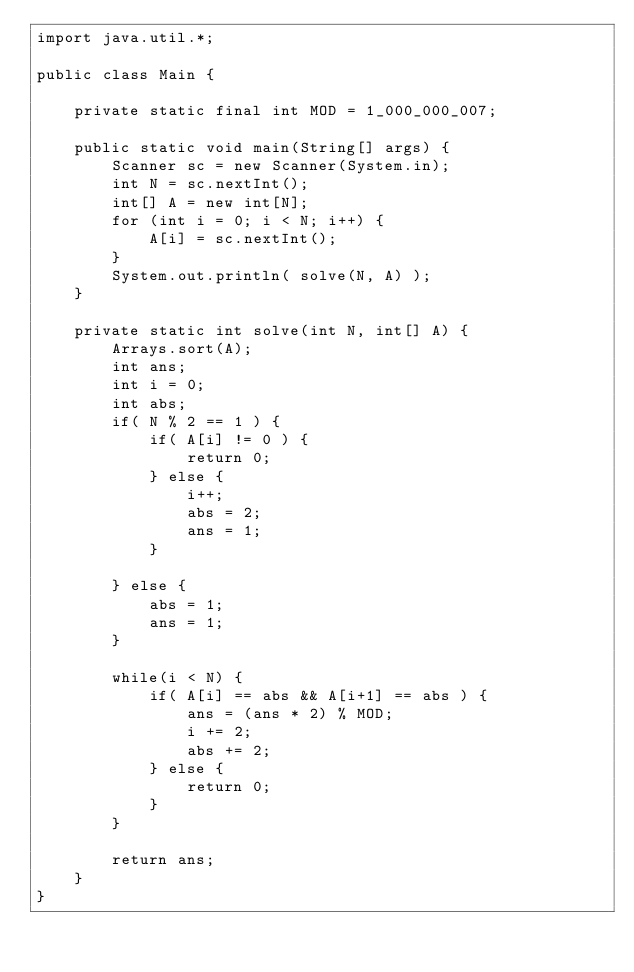Convert code to text. <code><loc_0><loc_0><loc_500><loc_500><_Java_>import java.util.*;

public class Main {

    private static final int MOD = 1_000_000_007;

    public static void main(String[] args) {
        Scanner sc = new Scanner(System.in);
        int N = sc.nextInt();
        int[] A = new int[N];
        for (int i = 0; i < N; i++) {
            A[i] = sc.nextInt();
        }
        System.out.println( solve(N, A) );
    }

    private static int solve(int N, int[] A) {
        Arrays.sort(A);
        int ans;
        int i = 0;
        int abs;
        if( N % 2 == 1 ) {
            if( A[i] != 0 ) {
                return 0;
            } else {
                i++;
                abs = 2;
                ans = 1;
            }

        } else {
            abs = 1;
            ans = 1;
        }

        while(i < N) {
            if( A[i] == abs && A[i+1] == abs ) {
                ans = (ans * 2) % MOD;
                i += 2;
                abs += 2;
            } else {
                return 0;
            }
        }

        return ans;
    }
}
</code> 